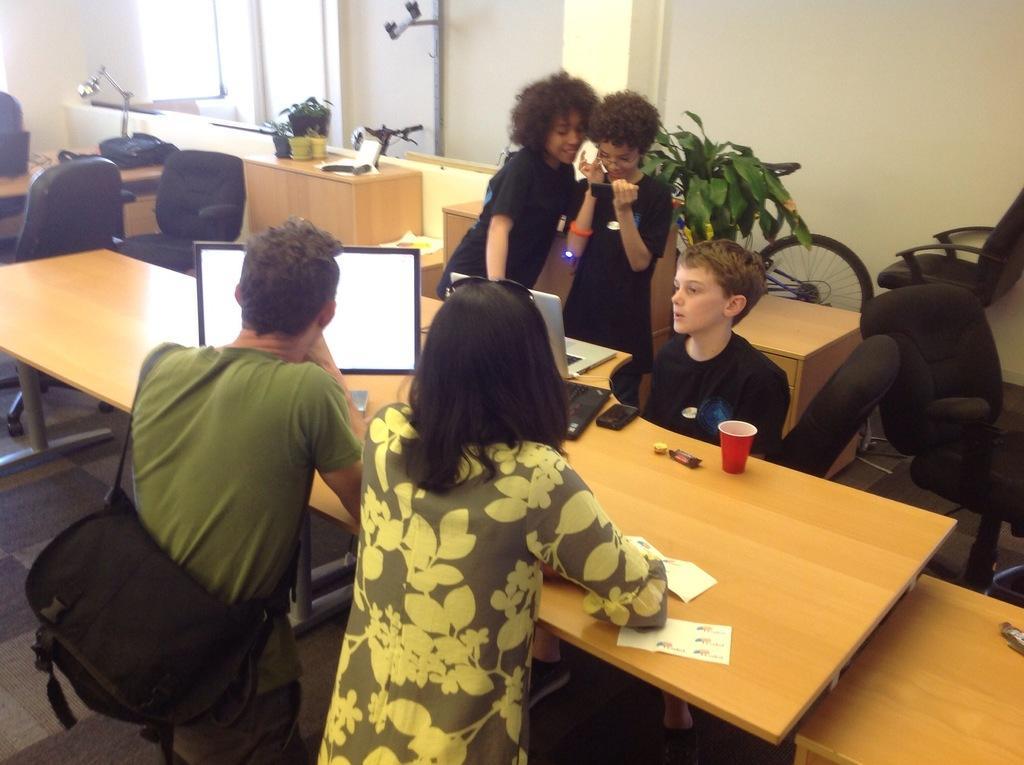How would you summarize this image in a sentence or two? The photo is taken inside a room. There are many chairs and tables. On the table there are laptops,cup,chocolate,plant pot,table lamp,papers. On the left side there are two person standing beside the table. Out of them one person wearing green t shirt is carrying a bag. In front of them there are three kids. The kid on the right is sitting,other two kid are standing. Out of them one is holding mobile. Behind them there is plant and a bicycle. 